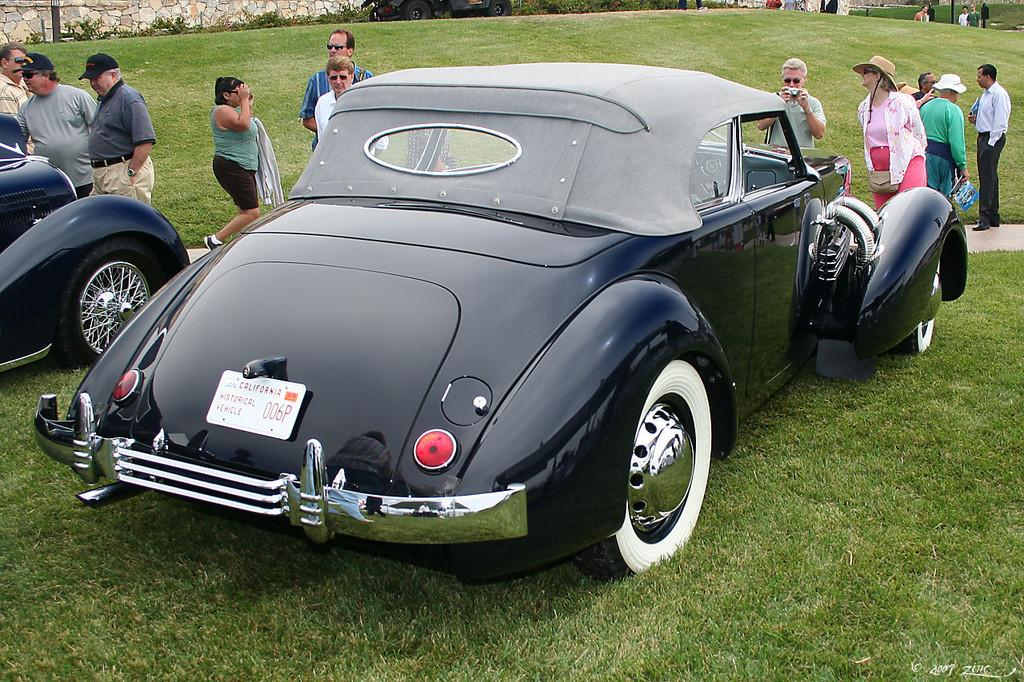What can be seen in the image involving people? There are people in the image, and one person is taking a picture using a camera, while another person is holding a book. What else is present in the image besides people? There are vehicles and grass visible in the image. Additionally, there is a wall in the image. Can you see any ants crawling on the book in the image? There are no ants visible in the image, and therefore none can be seen crawling on the book. 